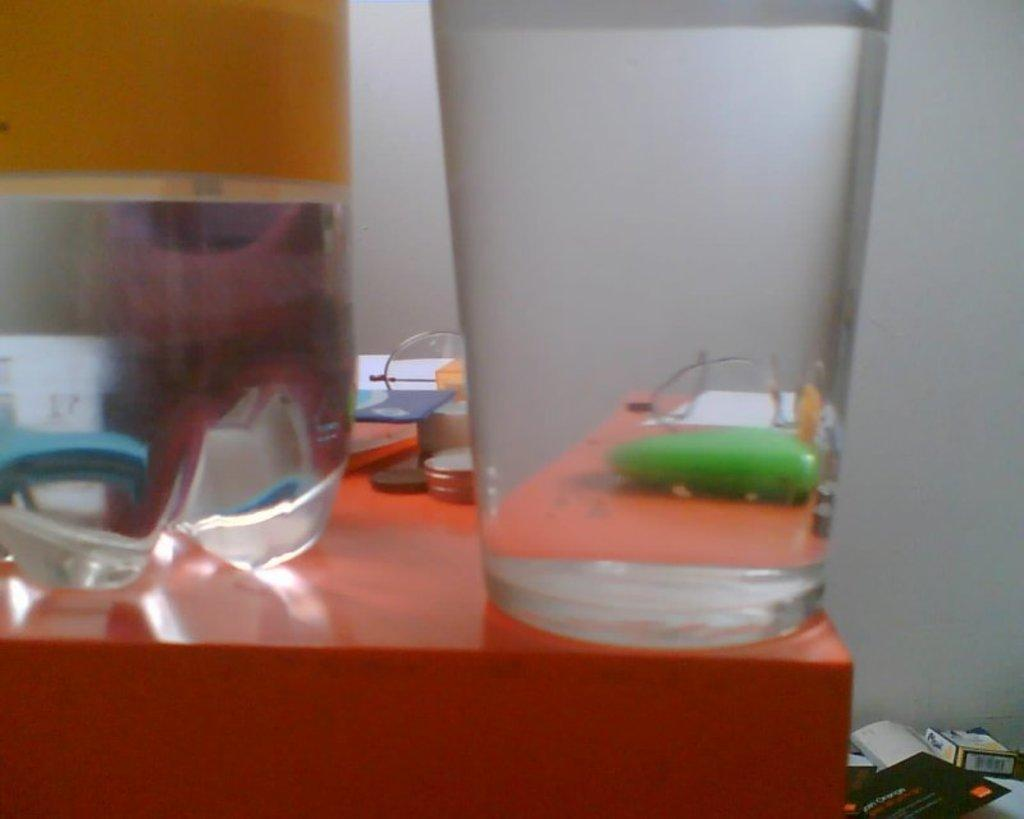What type of container is visible in the image? There is a glass in the image. What other type of container is present in the image? There is a water bottle in the image. What can be found on the desk in the image? There are items on the desk. Where are the books located in the image? There are books in the right corner of the image. What is visible behind the books in the image? There is a wall visible behind the books. How is the air distributed in the image? There is no specific mention of air distribution in the image, as it focuses on the containers and items present. 